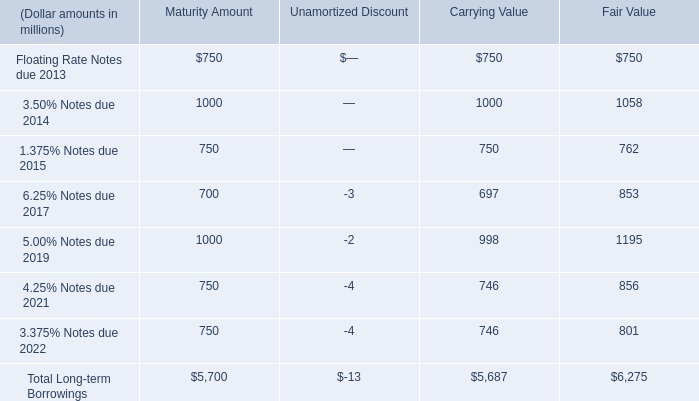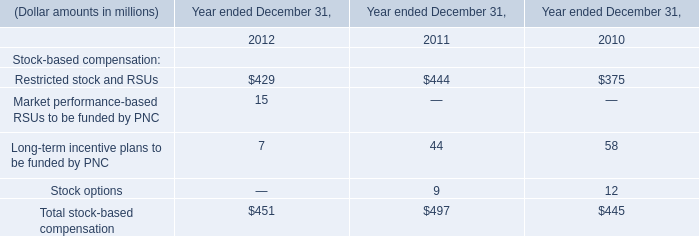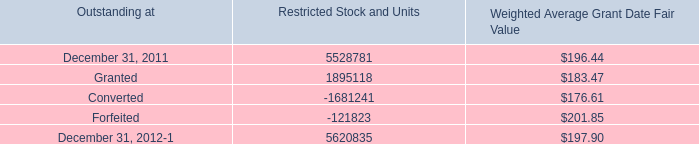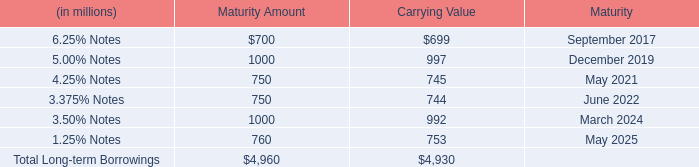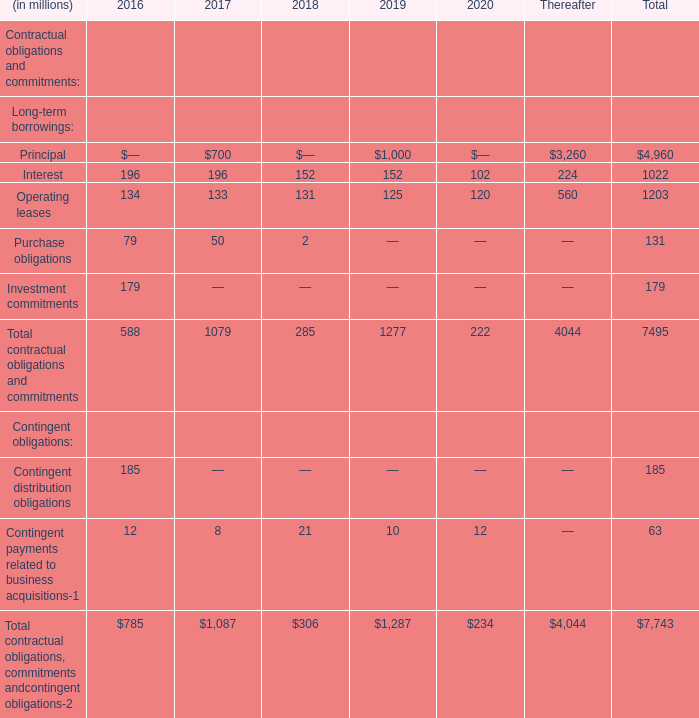If Interest develops with the same growth rate in 2018, what will it reach in 2019? (in million) 
Computations: (152 + ((152 * (152 - 196)) / 196))
Answer: 117.87755. 